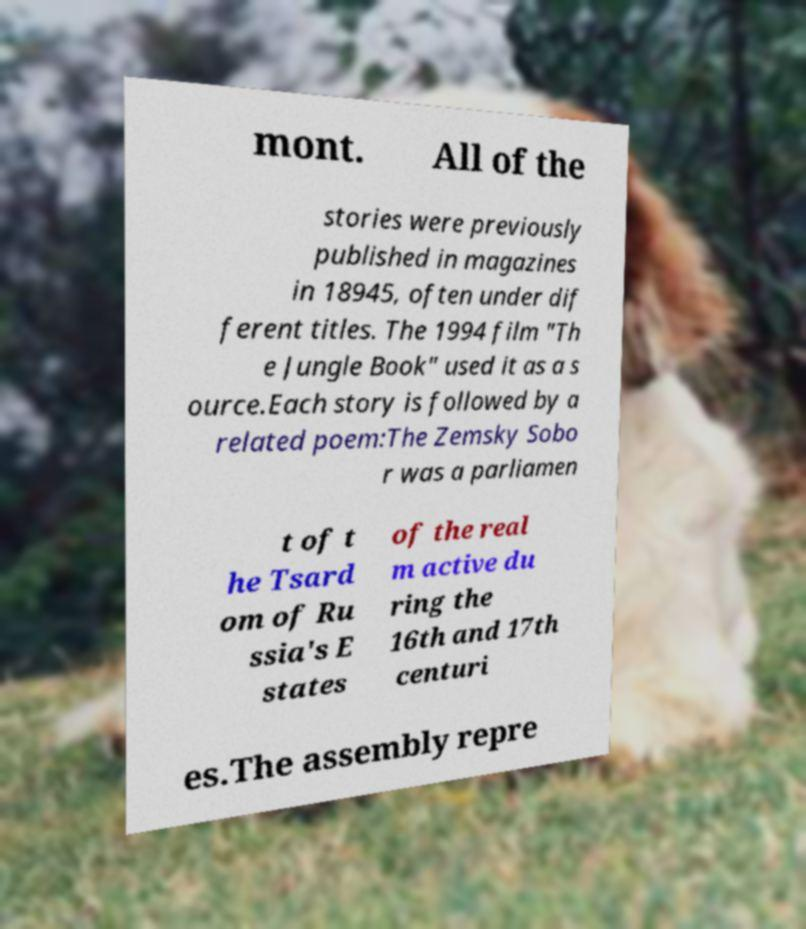Can you accurately transcribe the text from the provided image for me? mont. All of the stories were previously published in magazines in 18945, often under dif ferent titles. The 1994 film "Th e Jungle Book" used it as a s ource.Each story is followed by a related poem:The Zemsky Sobo r was a parliamen t of t he Tsard om of Ru ssia's E states of the real m active du ring the 16th and 17th centuri es.The assembly repre 